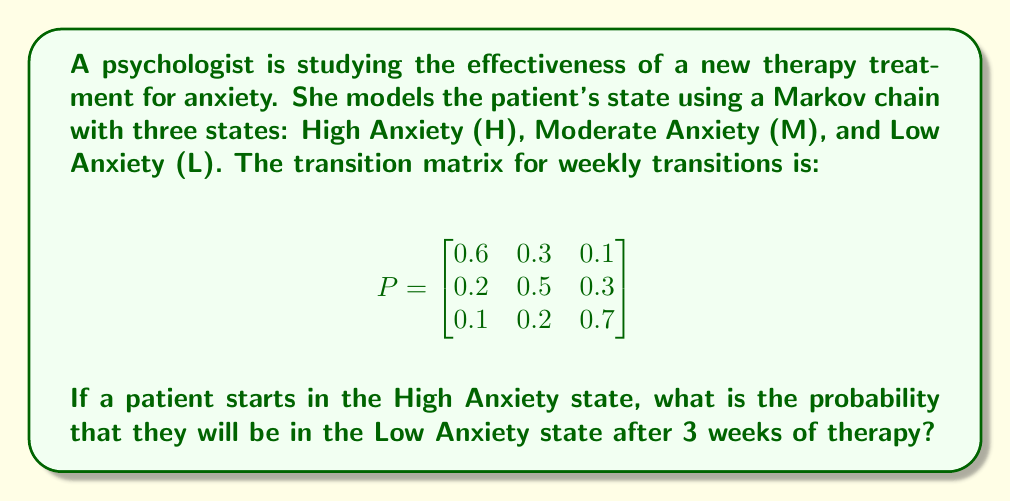Solve this math problem. To solve this problem, we need to use the Markov chain transition matrix and raise it to the power of 3 (for 3 weeks). Then, we'll look at the probability of transitioning from High Anxiety to Low Anxiety.

Step 1: Calculate $P^3$
$$P^3 = P \times P \times P$$

We can use matrix multiplication or a computer algebra system to calculate this. The result is:

$$P^3 \approx \begin{bmatrix}
0.416 & 0.354 & 0.230 \\
0.308 & 0.374 & 0.318 \\
0.216 & 0.282 & 0.502
\end{bmatrix}$$

Step 2: Identify the relevant probability
The probability we're looking for is the transition from High Anxiety (first row) to Low Anxiety (third column) after 3 weeks. This is the element in the first row, third column of $P^3$.

Step 3: Read the probability
The probability of transitioning from High Anxiety to Low Anxiety after 3 weeks is approximately 0.230 or 23.0%.
Answer: 0.230 